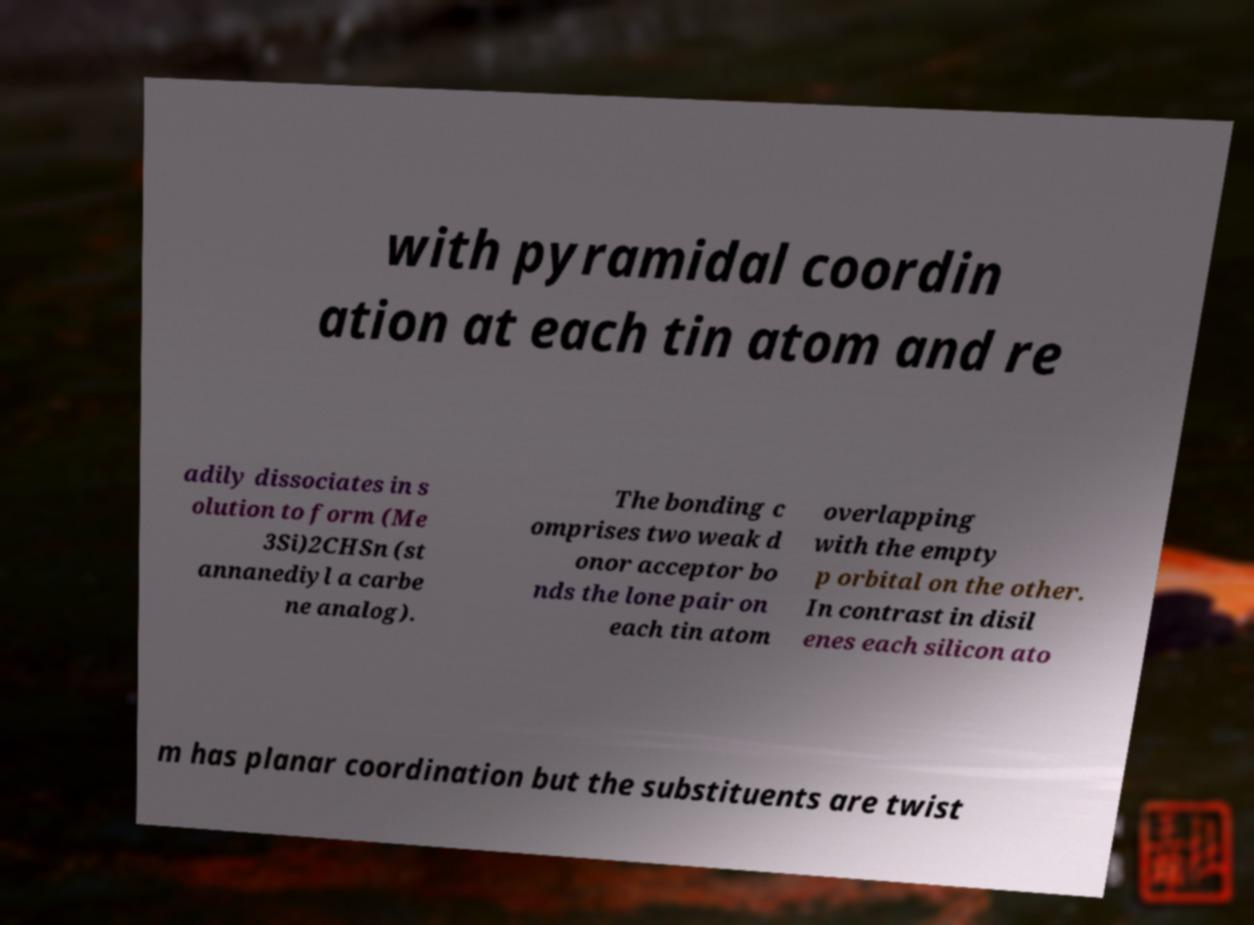Could you extract and type out the text from this image? with pyramidal coordin ation at each tin atom and re adily dissociates in s olution to form (Me 3Si)2CHSn (st annanediyl a carbe ne analog). The bonding c omprises two weak d onor acceptor bo nds the lone pair on each tin atom overlapping with the empty p orbital on the other. In contrast in disil enes each silicon ato m has planar coordination but the substituents are twist 